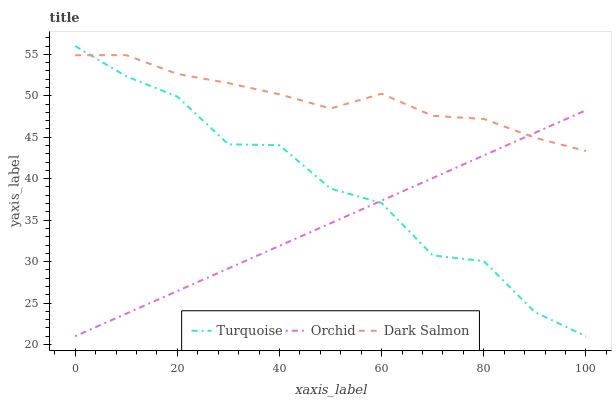Does Orchid have the minimum area under the curve?
Answer yes or no. Yes. Does Dark Salmon have the maximum area under the curve?
Answer yes or no. Yes. Does Dark Salmon have the minimum area under the curve?
Answer yes or no. No. Does Orchid have the maximum area under the curve?
Answer yes or no. No. Is Orchid the smoothest?
Answer yes or no. Yes. Is Turquoise the roughest?
Answer yes or no. Yes. Is Dark Salmon the smoothest?
Answer yes or no. No. Is Dark Salmon the roughest?
Answer yes or no. No. Does Turquoise have the lowest value?
Answer yes or no. Yes. Does Dark Salmon have the lowest value?
Answer yes or no. No. Does Turquoise have the highest value?
Answer yes or no. Yes. Does Dark Salmon have the highest value?
Answer yes or no. No. Does Turquoise intersect Orchid?
Answer yes or no. Yes. Is Turquoise less than Orchid?
Answer yes or no. No. Is Turquoise greater than Orchid?
Answer yes or no. No. 